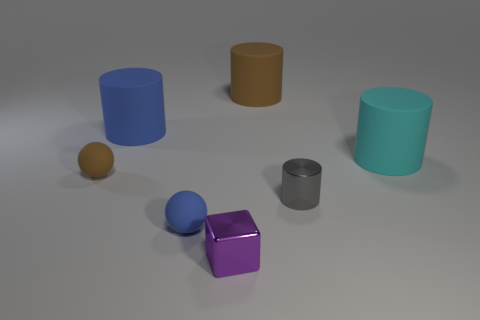What number of objects are either big purple rubber blocks or small matte balls that are in front of the gray metallic object?
Offer a terse response. 1. Is the number of small purple shiny objects less than the number of rubber cylinders?
Your answer should be very brief. Yes. What color is the tiny cylinder that is on the right side of the big rubber object on the left side of the big brown thing?
Keep it short and to the point. Gray. There is a cyan thing that is the same shape as the gray shiny thing; what is its material?
Give a very brief answer. Rubber. What number of rubber objects are big yellow cubes or large blue cylinders?
Make the answer very short. 1. Is the material of the brown object to the left of the purple cube the same as the large blue object right of the small brown matte sphere?
Give a very brief answer. Yes. Is there a large blue object?
Ensure brevity in your answer.  Yes. There is a brown rubber object to the right of the tiny brown sphere; does it have the same shape as the brown object left of the blue matte ball?
Ensure brevity in your answer.  No. Are there any large cyan blocks made of the same material as the small brown object?
Give a very brief answer. No. Is the small object that is to the right of the big brown object made of the same material as the cube?
Ensure brevity in your answer.  Yes. 